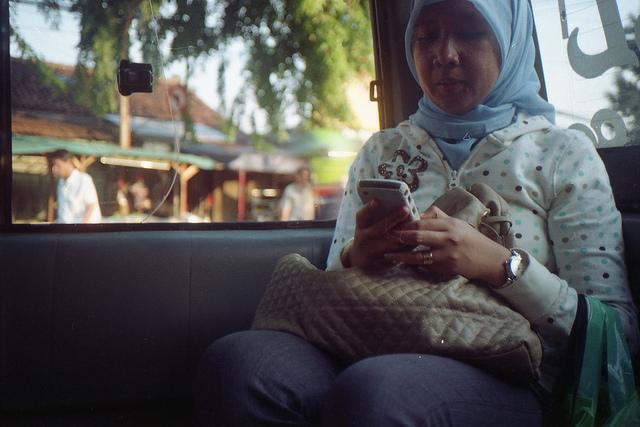What is one name for the type of headwear the woman is wearing?

Choices:
A) veil
B) cap
C) tie
D) hat veil 